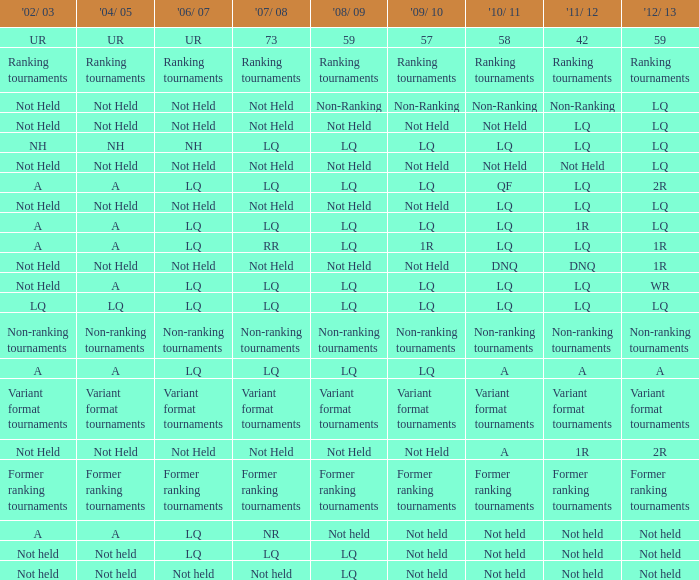Help me parse the entirety of this table. {'header': ["'02/ 03", "'04/ 05", "'06/ 07", "'07/ 08", "'08/ 09", "'09/ 10", "'10/ 11", "'11/ 12", "'12/ 13"], 'rows': [['UR', 'UR', 'UR', '73', '59', '57', '58', '42', '59'], ['Ranking tournaments', 'Ranking tournaments', 'Ranking tournaments', 'Ranking tournaments', 'Ranking tournaments', 'Ranking tournaments', 'Ranking tournaments', 'Ranking tournaments', 'Ranking tournaments'], ['Not Held', 'Not Held', 'Not Held', 'Not Held', 'Non-Ranking', 'Non-Ranking', 'Non-Ranking', 'Non-Ranking', 'LQ'], ['Not Held', 'Not Held', 'Not Held', 'Not Held', 'Not Held', 'Not Held', 'Not Held', 'LQ', 'LQ'], ['NH', 'NH', 'NH', 'LQ', 'LQ', 'LQ', 'LQ', 'LQ', 'LQ'], ['Not Held', 'Not Held', 'Not Held', 'Not Held', 'Not Held', 'Not Held', 'Not Held', 'Not Held', 'LQ'], ['A', 'A', 'LQ', 'LQ', 'LQ', 'LQ', 'QF', 'LQ', '2R'], ['Not Held', 'Not Held', 'Not Held', 'Not Held', 'Not Held', 'Not Held', 'LQ', 'LQ', 'LQ'], ['A', 'A', 'LQ', 'LQ', 'LQ', 'LQ', 'LQ', '1R', 'LQ'], ['A', 'A', 'LQ', 'RR', 'LQ', '1R', 'LQ', 'LQ', '1R'], ['Not Held', 'Not Held', 'Not Held', 'Not Held', 'Not Held', 'Not Held', 'DNQ', 'DNQ', '1R'], ['Not Held', 'A', 'LQ', 'LQ', 'LQ', 'LQ', 'LQ', 'LQ', 'WR'], ['LQ', 'LQ', 'LQ', 'LQ', 'LQ', 'LQ', 'LQ', 'LQ', 'LQ'], ['Non-ranking tournaments', 'Non-ranking tournaments', 'Non-ranking tournaments', 'Non-ranking tournaments', 'Non-ranking tournaments', 'Non-ranking tournaments', 'Non-ranking tournaments', 'Non-ranking tournaments', 'Non-ranking tournaments'], ['A', 'A', 'LQ', 'LQ', 'LQ', 'LQ', 'A', 'A', 'A'], ['Variant format tournaments', 'Variant format tournaments', 'Variant format tournaments', 'Variant format tournaments', 'Variant format tournaments', 'Variant format tournaments', 'Variant format tournaments', 'Variant format tournaments', 'Variant format tournaments'], ['Not Held', 'Not Held', 'Not Held', 'Not Held', 'Not Held', 'Not Held', 'A', '1R', '2R'], ['Former ranking tournaments', 'Former ranking tournaments', 'Former ranking tournaments', 'Former ranking tournaments', 'Former ranking tournaments', 'Former ranking tournaments', 'Former ranking tournaments', 'Former ranking tournaments', 'Former ranking tournaments'], ['A', 'A', 'LQ', 'NR', 'Not held', 'Not held', 'Not held', 'Not held', 'Not held'], ['Not held', 'Not held', 'LQ', 'LQ', 'LQ', 'Not held', 'Not held', 'Not held', 'Not held'], ['Not held', 'Not held', 'Not held', 'Not held', 'LQ', 'Not held', 'Not held', 'Not held', 'Not held']]} Specify the 2008/09 in conjunction with 2004/05 of ranking competitions. Ranking tournaments. 